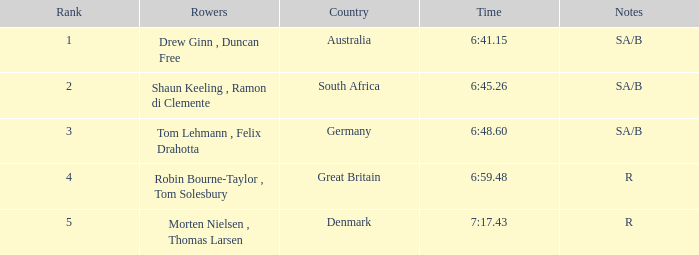For the rowers representing great britain, what was their time? 6:59.48. 